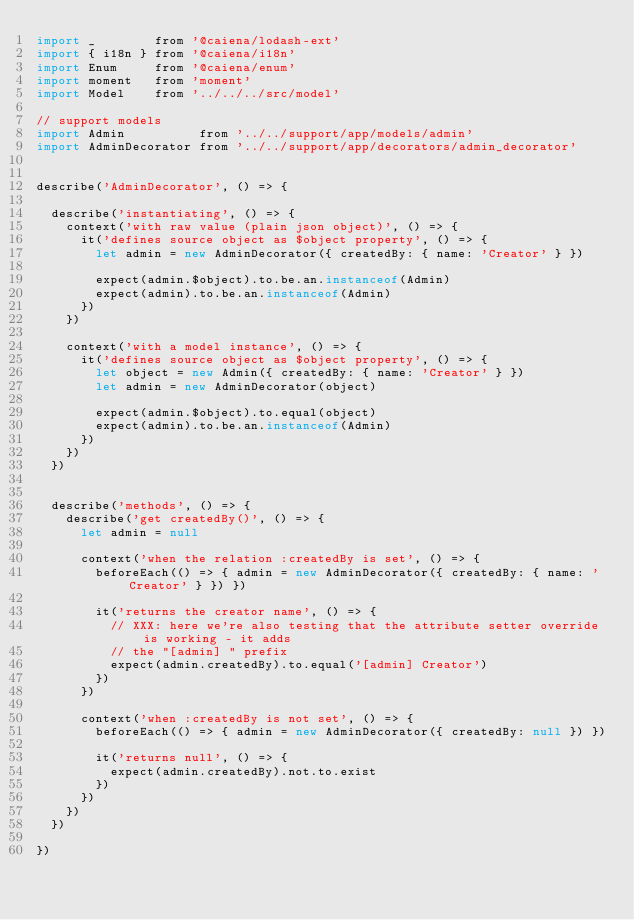Convert code to text. <code><loc_0><loc_0><loc_500><loc_500><_JavaScript_>import _        from '@caiena/lodash-ext'
import { i18n } from '@caiena/i18n'
import Enum     from '@caiena/enum'
import moment   from 'moment'
import Model    from '../../../src/model'

// support models
import Admin          from '../../support/app/models/admin'
import AdminDecorator from '../../support/app/decorators/admin_decorator'


describe('AdminDecorator', () => {

  describe('instantiating', () => {
    context('with raw value (plain json object)', () => {
      it('defines source object as $object property', () => {
        let admin = new AdminDecorator({ createdBy: { name: 'Creator' } })

        expect(admin.$object).to.be.an.instanceof(Admin)
        expect(admin).to.be.an.instanceof(Admin)
      })
    })

    context('with a model instance', () => {
      it('defines source object as $object property', () => {
        let object = new Admin({ createdBy: { name: 'Creator' } })
        let admin = new AdminDecorator(object)

        expect(admin.$object).to.equal(object)
        expect(admin).to.be.an.instanceof(Admin)
      })
    })
  })


  describe('methods', () => {
    describe('get createdBy()', () => {
      let admin = null

      context('when the relation :createdBy is set', () => {
        beforeEach(() => { admin = new AdminDecorator({ createdBy: { name: 'Creator' } }) })

        it('returns the creator name', () => {
          // XXX: here we're also testing that the attribute setter override is working - it adds
          // the "[admin] " prefix
          expect(admin.createdBy).to.equal('[admin] Creator')
        })
      })

      context('when :createdBy is not set', () => {
        beforeEach(() => { admin = new AdminDecorator({ createdBy: null }) })

        it('returns null', () => {
          expect(admin.createdBy).not.to.exist
        })
      })
    })
  })

})
</code> 